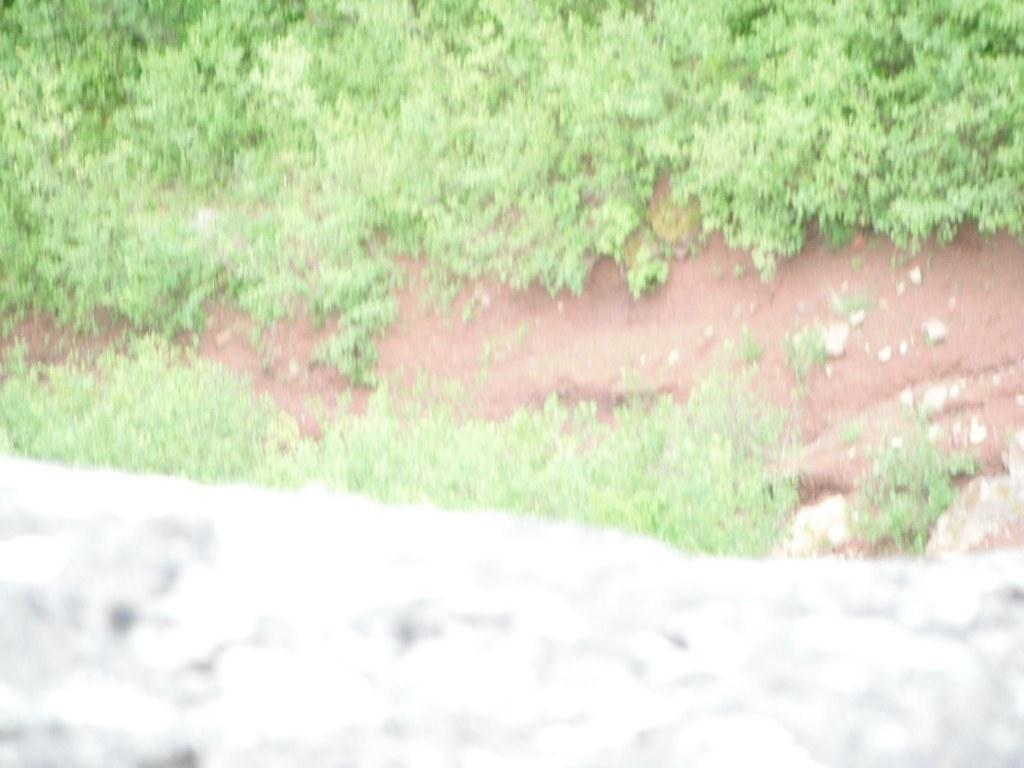What type of vegetation is present in the image? There is grass in the image. What structure is in front of the grass in the image? There is a cement wall in front of the grass in the image. Can you see a kitten dropping a suggestion in the image? There is no kitten or suggestion present in the image. 